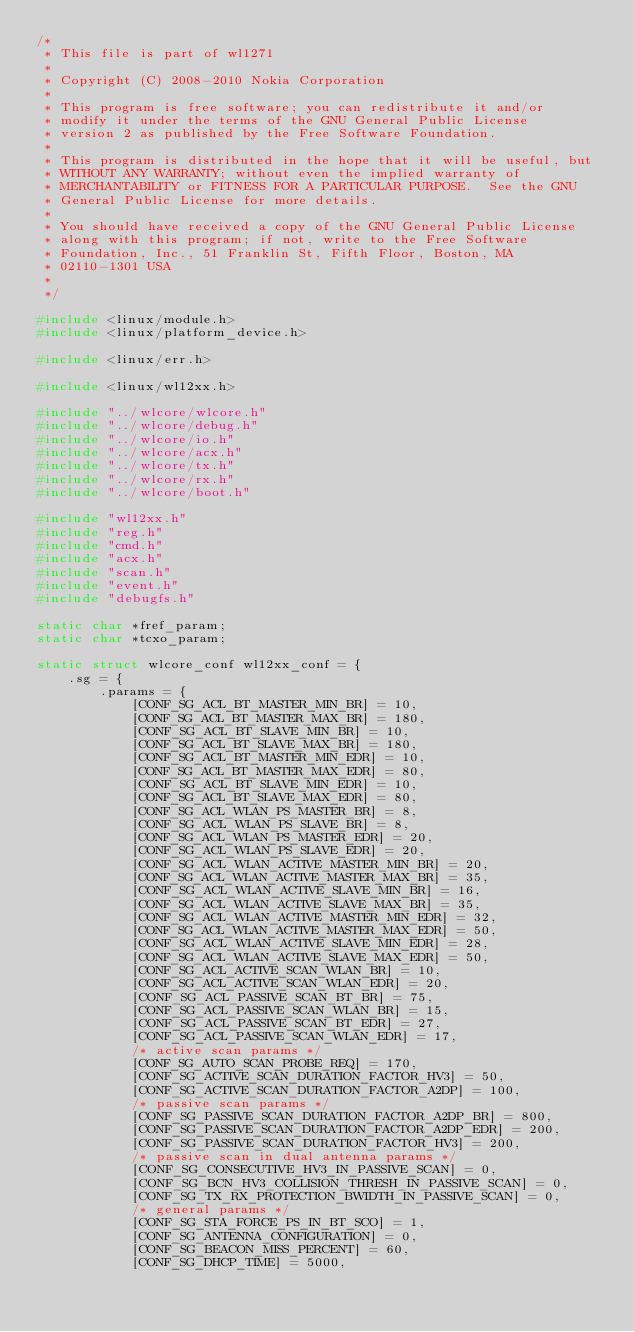Convert code to text. <code><loc_0><loc_0><loc_500><loc_500><_C_>/*
 * This file is part of wl1271
 *
 * Copyright (C) 2008-2010 Nokia Corporation
 *
 * This program is free software; you can redistribute it and/or
 * modify it under the terms of the GNU General Public License
 * version 2 as published by the Free Software Foundation.
 *
 * This program is distributed in the hope that it will be useful, but
 * WITHOUT ANY WARRANTY; without even the implied warranty of
 * MERCHANTABILITY or FITNESS FOR A PARTICULAR PURPOSE.  See the GNU
 * General Public License for more details.
 *
 * You should have received a copy of the GNU General Public License
 * along with this program; if not, write to the Free Software
 * Foundation, Inc., 51 Franklin St, Fifth Floor, Boston, MA
 * 02110-1301 USA
 *
 */

#include <linux/module.h>
#include <linux/platform_device.h>

#include <linux/err.h>

#include <linux/wl12xx.h>

#include "../wlcore/wlcore.h"
#include "../wlcore/debug.h"
#include "../wlcore/io.h"
#include "../wlcore/acx.h"
#include "../wlcore/tx.h"
#include "../wlcore/rx.h"
#include "../wlcore/boot.h"

#include "wl12xx.h"
#include "reg.h"
#include "cmd.h"
#include "acx.h"
#include "scan.h"
#include "event.h"
#include "debugfs.h"

static char *fref_param;
static char *tcxo_param;

static struct wlcore_conf wl12xx_conf = {
	.sg = {
		.params = {
			[CONF_SG_ACL_BT_MASTER_MIN_BR] = 10,
			[CONF_SG_ACL_BT_MASTER_MAX_BR] = 180,
			[CONF_SG_ACL_BT_SLAVE_MIN_BR] = 10,
			[CONF_SG_ACL_BT_SLAVE_MAX_BR] = 180,
			[CONF_SG_ACL_BT_MASTER_MIN_EDR] = 10,
			[CONF_SG_ACL_BT_MASTER_MAX_EDR] = 80,
			[CONF_SG_ACL_BT_SLAVE_MIN_EDR] = 10,
			[CONF_SG_ACL_BT_SLAVE_MAX_EDR] = 80,
			[CONF_SG_ACL_WLAN_PS_MASTER_BR] = 8,
			[CONF_SG_ACL_WLAN_PS_SLAVE_BR] = 8,
			[CONF_SG_ACL_WLAN_PS_MASTER_EDR] = 20,
			[CONF_SG_ACL_WLAN_PS_SLAVE_EDR] = 20,
			[CONF_SG_ACL_WLAN_ACTIVE_MASTER_MIN_BR] = 20,
			[CONF_SG_ACL_WLAN_ACTIVE_MASTER_MAX_BR] = 35,
			[CONF_SG_ACL_WLAN_ACTIVE_SLAVE_MIN_BR] = 16,
			[CONF_SG_ACL_WLAN_ACTIVE_SLAVE_MAX_BR] = 35,
			[CONF_SG_ACL_WLAN_ACTIVE_MASTER_MIN_EDR] = 32,
			[CONF_SG_ACL_WLAN_ACTIVE_MASTER_MAX_EDR] = 50,
			[CONF_SG_ACL_WLAN_ACTIVE_SLAVE_MIN_EDR] = 28,
			[CONF_SG_ACL_WLAN_ACTIVE_SLAVE_MAX_EDR] = 50,
			[CONF_SG_ACL_ACTIVE_SCAN_WLAN_BR] = 10,
			[CONF_SG_ACL_ACTIVE_SCAN_WLAN_EDR] = 20,
			[CONF_SG_ACL_PASSIVE_SCAN_BT_BR] = 75,
			[CONF_SG_ACL_PASSIVE_SCAN_WLAN_BR] = 15,
			[CONF_SG_ACL_PASSIVE_SCAN_BT_EDR] = 27,
			[CONF_SG_ACL_PASSIVE_SCAN_WLAN_EDR] = 17,
			/* active scan params */
			[CONF_SG_AUTO_SCAN_PROBE_REQ] = 170,
			[CONF_SG_ACTIVE_SCAN_DURATION_FACTOR_HV3] = 50,
			[CONF_SG_ACTIVE_SCAN_DURATION_FACTOR_A2DP] = 100,
			/* passive scan params */
			[CONF_SG_PASSIVE_SCAN_DURATION_FACTOR_A2DP_BR] = 800,
			[CONF_SG_PASSIVE_SCAN_DURATION_FACTOR_A2DP_EDR] = 200,
			[CONF_SG_PASSIVE_SCAN_DURATION_FACTOR_HV3] = 200,
			/* passive scan in dual antenna params */
			[CONF_SG_CONSECUTIVE_HV3_IN_PASSIVE_SCAN] = 0,
			[CONF_SG_BCN_HV3_COLLISION_THRESH_IN_PASSIVE_SCAN] = 0,
			[CONF_SG_TX_RX_PROTECTION_BWIDTH_IN_PASSIVE_SCAN] = 0,
			/* general params */
			[CONF_SG_STA_FORCE_PS_IN_BT_SCO] = 1,
			[CONF_SG_ANTENNA_CONFIGURATION] = 0,
			[CONF_SG_BEACON_MISS_PERCENT] = 60,
			[CONF_SG_DHCP_TIME] = 5000,</code> 